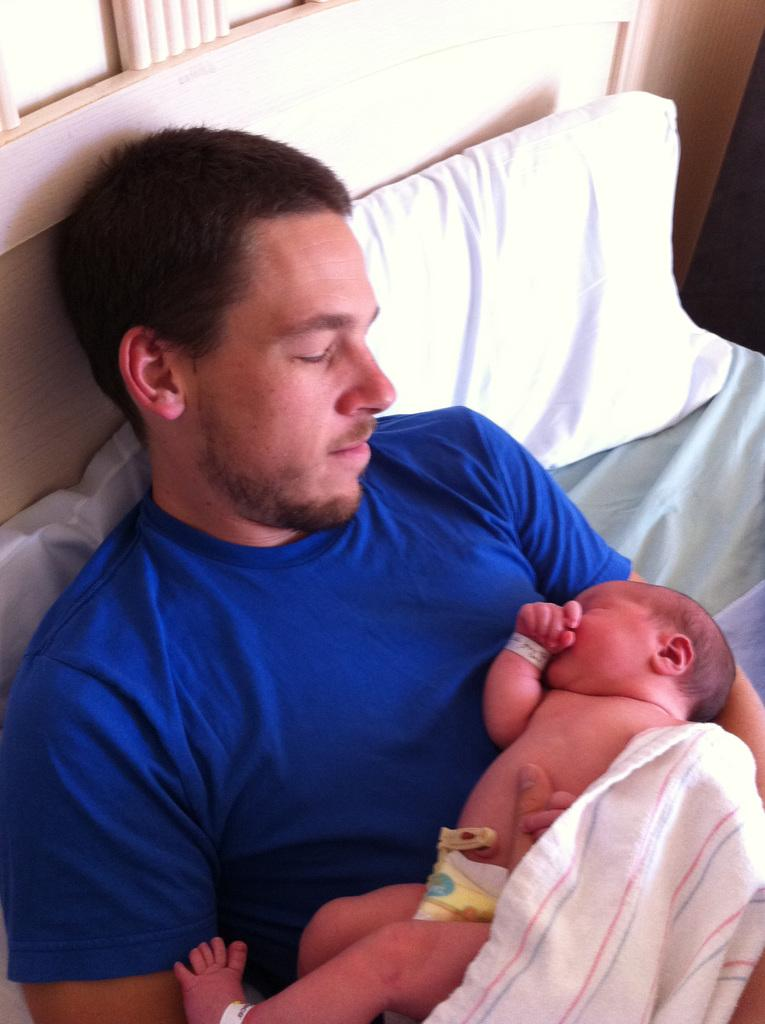Who is present in the image? There is a man in the image. What is the man wearing? The man is wearing a blue shirt. What is the man doing in the image? The man is lying on a bed and holding a baby. What else can be seen on the bed? There is a towel and a pillow on the bed. Can you see any deer in the image? No, there are no deer present in the image. Is the man in the image experiencing any pain? There is no indication of pain in the image; the man is lying on a bed holding a baby. 